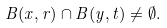Convert formula to latex. <formula><loc_0><loc_0><loc_500><loc_500>B ( x , r ) \cap B ( y , t ) \ne \emptyset .</formula> 